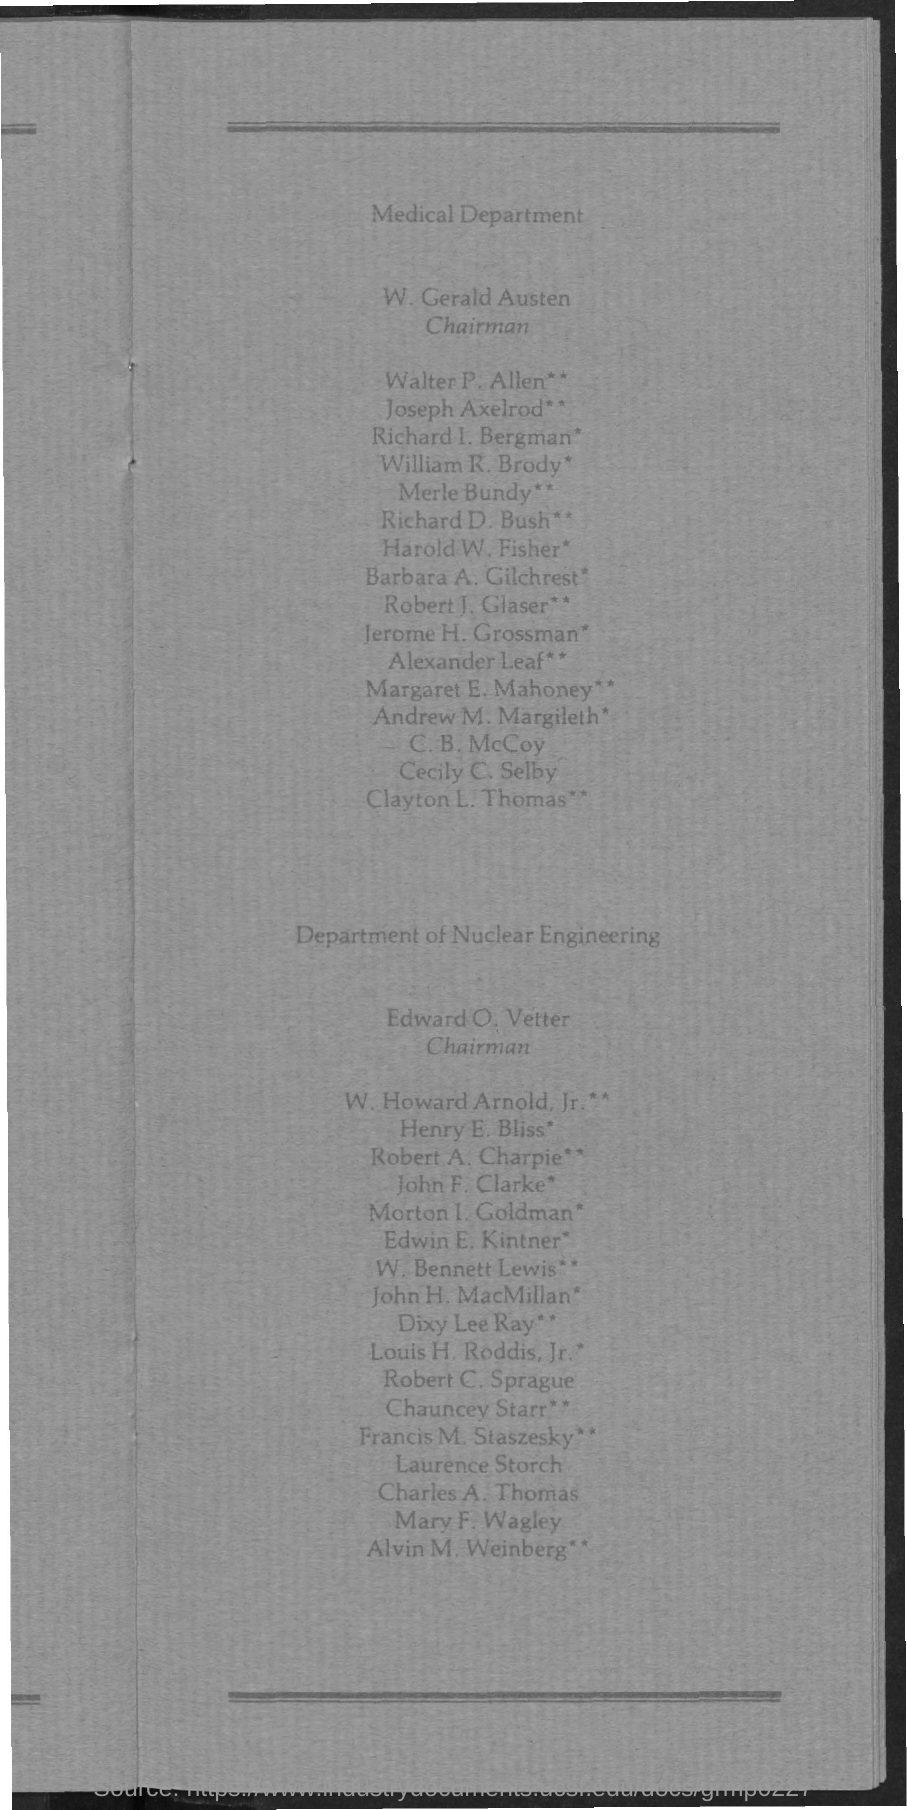Outline some significant characteristics in this image. It is confirmed that Edward O. Vetter is the Chairman of Nuclear Engineering. 